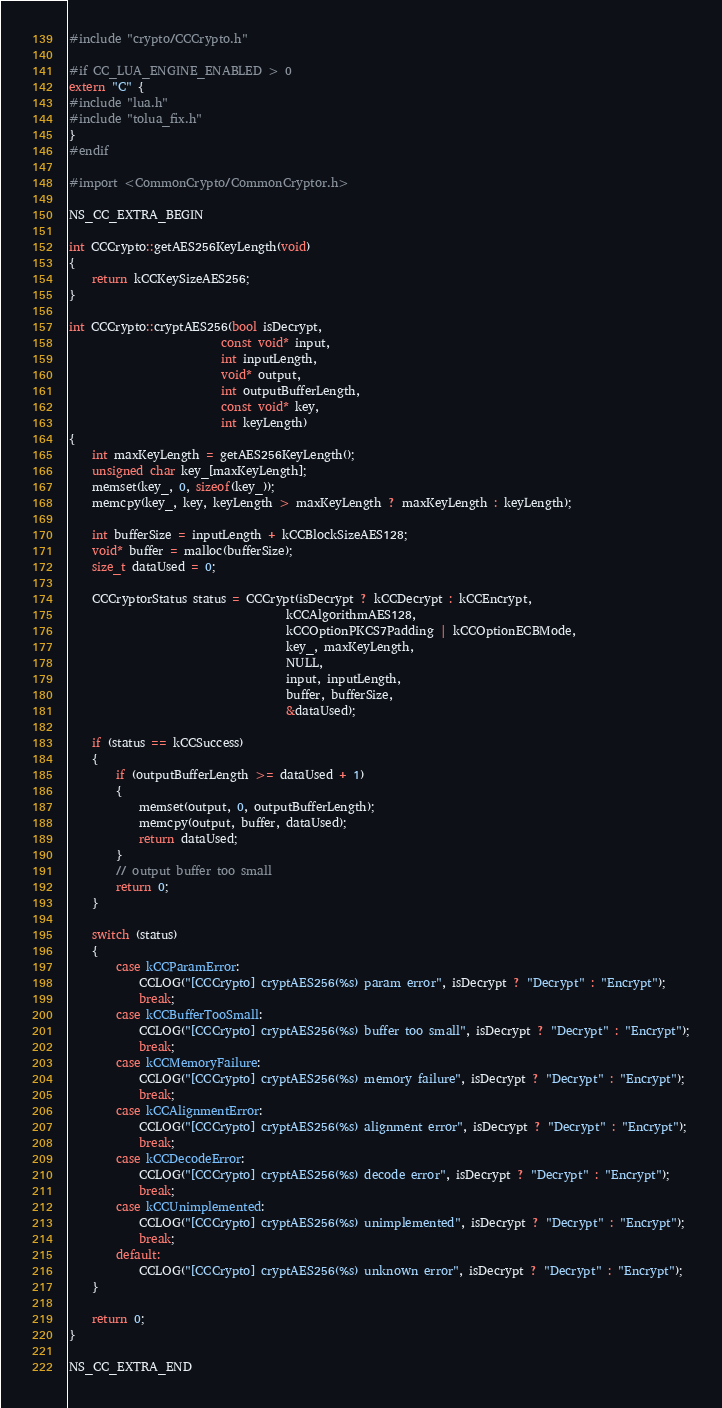Convert code to text. <code><loc_0><loc_0><loc_500><loc_500><_ObjectiveC_>
#include "crypto/CCCrypto.h"

#if CC_LUA_ENGINE_ENABLED > 0
extern "C" {
#include "lua.h"
#include "tolua_fix.h"
}
#endif

#import <CommonCrypto/CommonCryptor.h>

NS_CC_EXTRA_BEGIN

int CCCrypto::getAES256KeyLength(void)
{
    return kCCKeySizeAES256;
}

int CCCrypto::cryptAES256(bool isDecrypt,
                          const void* input,
                          int inputLength,
                          void* output,
                          int outputBufferLength,
                          const void* key,
                          int keyLength)
{
    int maxKeyLength = getAES256KeyLength();
    unsigned char key_[maxKeyLength];
    memset(key_, 0, sizeof(key_));
    memcpy(key_, key, keyLength > maxKeyLength ? maxKeyLength : keyLength);

    int bufferSize = inputLength + kCCBlockSizeAES128;
    void* buffer = malloc(bufferSize);
    size_t dataUsed = 0;

    CCCryptorStatus status = CCCrypt(isDecrypt ? kCCDecrypt : kCCEncrypt,
                                     kCCAlgorithmAES128,
                                     kCCOptionPKCS7Padding | kCCOptionECBMode,
                                     key_, maxKeyLength,
                                     NULL,
                                     input, inputLength,
                                     buffer, bufferSize,
                                     &dataUsed);

    if (status == kCCSuccess)
    {
        if (outputBufferLength >= dataUsed + 1)
        {
            memset(output, 0, outputBufferLength);
            memcpy(output, buffer, dataUsed);
            return dataUsed;
        }
        // output buffer too small
        return 0;
    }

    switch (status)
    {
        case kCCParamError:
            CCLOG("[CCCrypto] cryptAES256(%s) param error", isDecrypt ? "Decrypt" : "Encrypt");
            break;
        case kCCBufferTooSmall:
            CCLOG("[CCCrypto] cryptAES256(%s) buffer too small", isDecrypt ? "Decrypt" : "Encrypt");
            break;
        case kCCMemoryFailure:
            CCLOG("[CCCrypto] cryptAES256(%s) memory failure", isDecrypt ? "Decrypt" : "Encrypt");
            break;
        case kCCAlignmentError:
            CCLOG("[CCCrypto] cryptAES256(%s) alignment error", isDecrypt ? "Decrypt" : "Encrypt");
            break;
        case kCCDecodeError:
            CCLOG("[CCCrypto] cryptAES256(%s) decode error", isDecrypt ? "Decrypt" : "Encrypt");
            break;
        case kCCUnimplemented:
            CCLOG("[CCCrypto] cryptAES256(%s) unimplemented", isDecrypt ? "Decrypt" : "Encrypt");
            break;
        default:
            CCLOG("[CCCrypto] cryptAES256(%s) unknown error", isDecrypt ? "Decrypt" : "Encrypt");
    }

    return 0;
}

NS_CC_EXTRA_END
</code> 